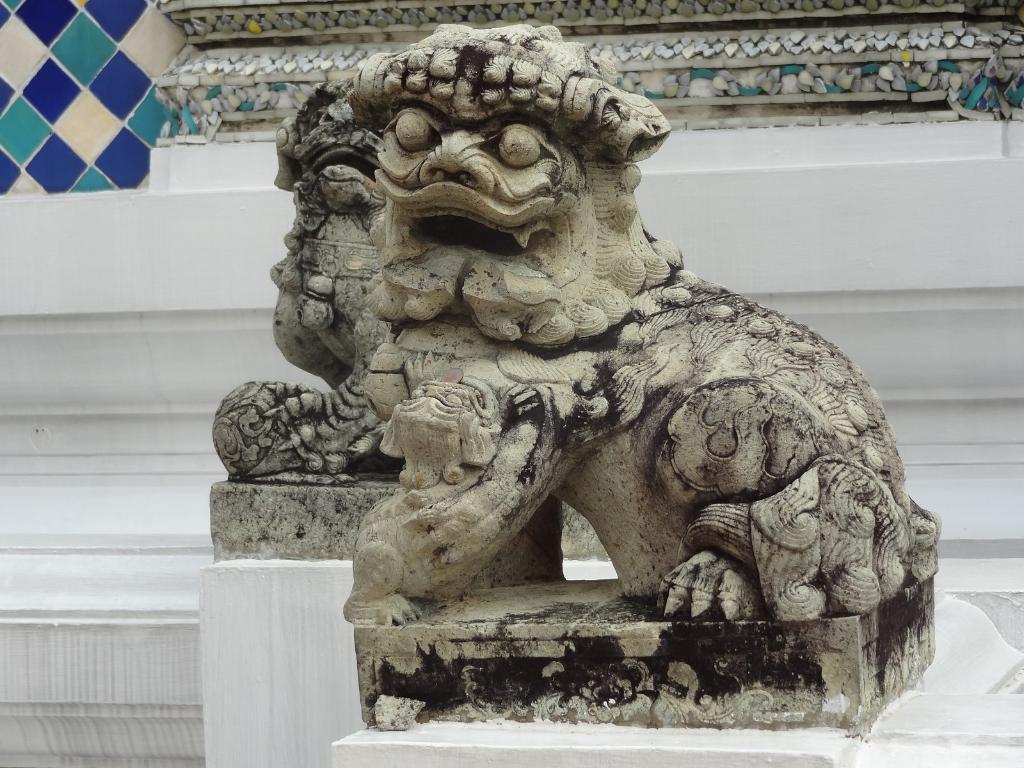Please provide a concise description of this image. In this image we can see a statue. 